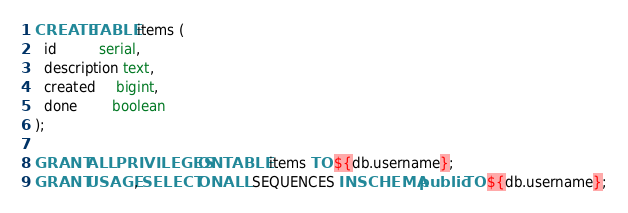<code> <loc_0><loc_0><loc_500><loc_500><_SQL_>CREATE TABLE items (
  id          serial,
  description text,
  created     bigint,
  done        boolean
);

GRANT ALL PRIVILEGES ON TABLE items TO ${db.username};
GRANT USAGE, SELECT ON ALL SEQUENCES IN SCHEMA public TO ${db.username};</code> 